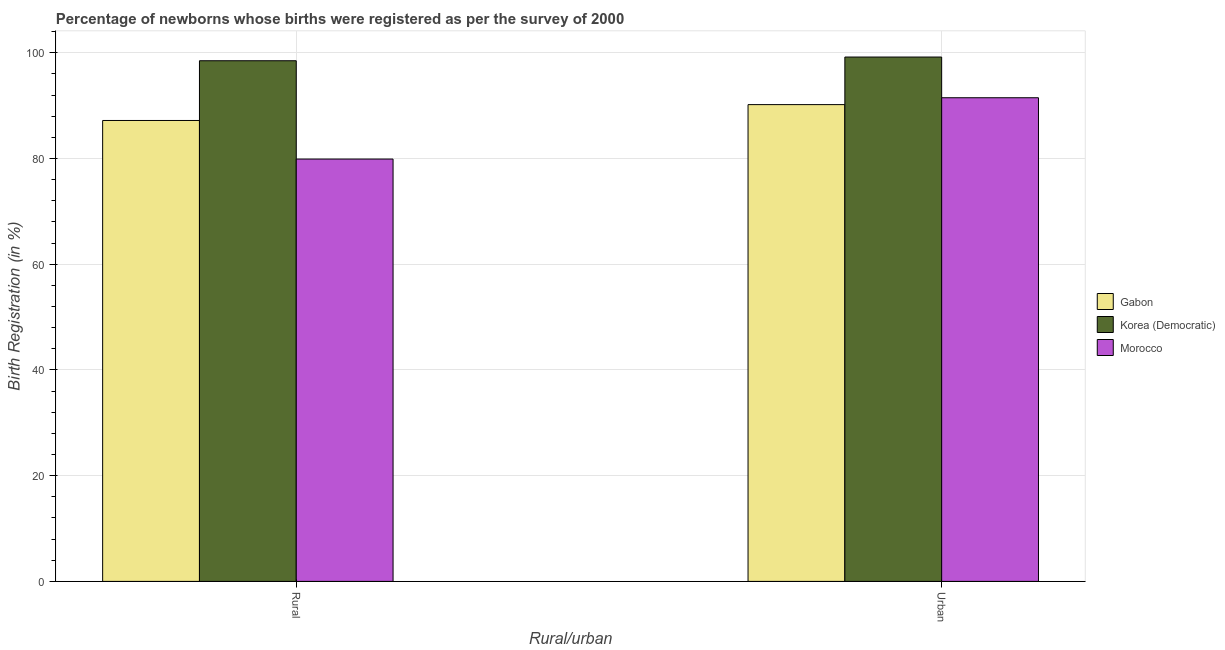How many different coloured bars are there?
Make the answer very short. 3. How many groups of bars are there?
Give a very brief answer. 2. Are the number of bars per tick equal to the number of legend labels?
Ensure brevity in your answer.  Yes. Are the number of bars on each tick of the X-axis equal?
Your answer should be compact. Yes. What is the label of the 1st group of bars from the left?
Provide a succinct answer. Rural. What is the rural birth registration in Morocco?
Provide a short and direct response. 79.9. Across all countries, what is the maximum urban birth registration?
Your answer should be very brief. 99.2. Across all countries, what is the minimum rural birth registration?
Your answer should be compact. 79.9. In which country was the rural birth registration maximum?
Your response must be concise. Korea (Democratic). In which country was the urban birth registration minimum?
Offer a terse response. Gabon. What is the total rural birth registration in the graph?
Provide a short and direct response. 265.6. What is the difference between the rural birth registration in Korea (Democratic) and that in Gabon?
Give a very brief answer. 11.3. What is the difference between the rural birth registration in Gabon and the urban birth registration in Morocco?
Your answer should be compact. -4.3. What is the average rural birth registration per country?
Your response must be concise. 88.53. What is the difference between the urban birth registration and rural birth registration in Korea (Democratic)?
Your response must be concise. 0.7. What is the ratio of the urban birth registration in Korea (Democratic) to that in Gabon?
Offer a terse response. 1.1. In how many countries, is the rural birth registration greater than the average rural birth registration taken over all countries?
Offer a terse response. 1. What does the 1st bar from the left in Urban represents?
Give a very brief answer. Gabon. What does the 3rd bar from the right in Urban represents?
Offer a very short reply. Gabon. How many bars are there?
Offer a terse response. 6. Does the graph contain any zero values?
Your answer should be compact. No. Does the graph contain grids?
Give a very brief answer. Yes. How many legend labels are there?
Offer a terse response. 3. What is the title of the graph?
Your answer should be compact. Percentage of newborns whose births were registered as per the survey of 2000. What is the label or title of the X-axis?
Make the answer very short. Rural/urban. What is the label or title of the Y-axis?
Provide a succinct answer. Birth Registration (in %). What is the Birth Registration (in %) in Gabon in Rural?
Provide a succinct answer. 87.2. What is the Birth Registration (in %) in Korea (Democratic) in Rural?
Make the answer very short. 98.5. What is the Birth Registration (in %) of Morocco in Rural?
Keep it short and to the point. 79.9. What is the Birth Registration (in %) in Gabon in Urban?
Your answer should be very brief. 90.2. What is the Birth Registration (in %) in Korea (Democratic) in Urban?
Provide a short and direct response. 99.2. What is the Birth Registration (in %) in Morocco in Urban?
Offer a very short reply. 91.5. Across all Rural/urban, what is the maximum Birth Registration (in %) of Gabon?
Offer a very short reply. 90.2. Across all Rural/urban, what is the maximum Birth Registration (in %) in Korea (Democratic)?
Offer a very short reply. 99.2. Across all Rural/urban, what is the maximum Birth Registration (in %) in Morocco?
Your response must be concise. 91.5. Across all Rural/urban, what is the minimum Birth Registration (in %) of Gabon?
Offer a terse response. 87.2. Across all Rural/urban, what is the minimum Birth Registration (in %) of Korea (Democratic)?
Your answer should be compact. 98.5. Across all Rural/urban, what is the minimum Birth Registration (in %) of Morocco?
Your response must be concise. 79.9. What is the total Birth Registration (in %) in Gabon in the graph?
Your answer should be very brief. 177.4. What is the total Birth Registration (in %) in Korea (Democratic) in the graph?
Your response must be concise. 197.7. What is the total Birth Registration (in %) in Morocco in the graph?
Give a very brief answer. 171.4. What is the difference between the Birth Registration (in %) of Gabon in Rural and the Birth Registration (in %) of Korea (Democratic) in Urban?
Provide a short and direct response. -12. What is the difference between the Birth Registration (in %) in Gabon in Rural and the Birth Registration (in %) in Morocco in Urban?
Your answer should be very brief. -4.3. What is the average Birth Registration (in %) in Gabon per Rural/urban?
Your response must be concise. 88.7. What is the average Birth Registration (in %) of Korea (Democratic) per Rural/urban?
Ensure brevity in your answer.  98.85. What is the average Birth Registration (in %) in Morocco per Rural/urban?
Ensure brevity in your answer.  85.7. What is the difference between the Birth Registration (in %) in Gabon and Birth Registration (in %) in Korea (Democratic) in Rural?
Ensure brevity in your answer.  -11.3. What is the difference between the Birth Registration (in %) of Gabon and Birth Registration (in %) of Morocco in Rural?
Your answer should be very brief. 7.3. What is the difference between the Birth Registration (in %) of Korea (Democratic) and Birth Registration (in %) of Morocco in Rural?
Give a very brief answer. 18.6. What is the difference between the Birth Registration (in %) in Korea (Democratic) and Birth Registration (in %) in Morocco in Urban?
Your answer should be compact. 7.7. What is the ratio of the Birth Registration (in %) in Gabon in Rural to that in Urban?
Your response must be concise. 0.97. What is the ratio of the Birth Registration (in %) of Morocco in Rural to that in Urban?
Make the answer very short. 0.87. What is the difference between the highest and the second highest Birth Registration (in %) of Gabon?
Your answer should be very brief. 3. What is the difference between the highest and the lowest Birth Registration (in %) in Gabon?
Ensure brevity in your answer.  3. What is the difference between the highest and the lowest Birth Registration (in %) in Korea (Democratic)?
Make the answer very short. 0.7. 